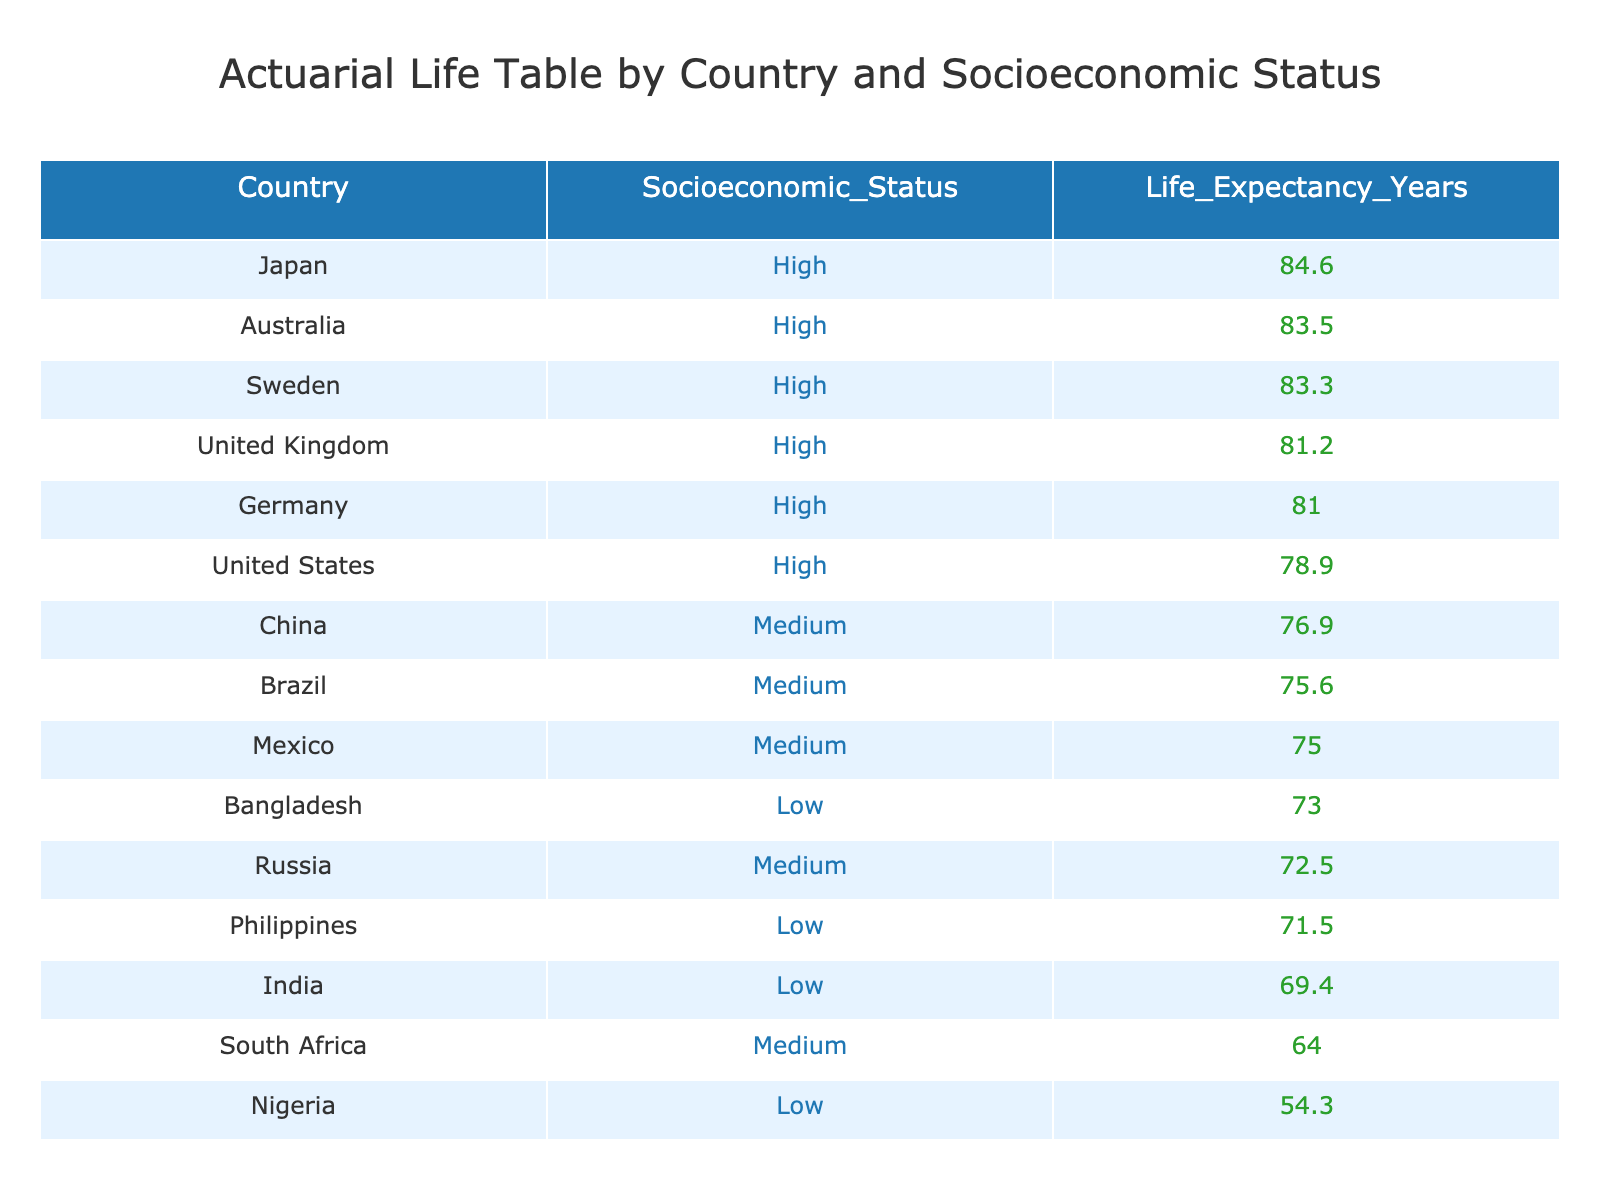What is the life expectancy in Japan? The table indicates that Japan has a life expectancy of 84.6 years.
Answer: 84.6 Which country has the lowest life expectancy? The table shows that Nigeria has the lowest life expectancy at 54.3 years.
Answer: 54.3 What is the average life expectancy for countries with high socioeconomic status? The life expectancy values for high socioeconomic status countries are 84.6 (Japan), 78.9 (United States), 81.0 (Germany), 83.3 (Sweden), and 83.5 (Australia). Summing these gives 84.6 + 78.9 + 81.0 + 83.3 + 83.5 = 411.3. Dividing by 5 gives an average of 82.26.
Answer: 82.26 Is the life expectancy in Brazil higher than that in South Africa? According to the table, Brazil's life expectancy is 75.6 years, while South Africa's is 64.0 years. Therefore, yes, Brazil has a higher life expectancy than South Africa.
Answer: Yes What is the difference in life expectancy between the highest and lowest country? The highest life expectancy is from Japan at 84.6 years, and the lowest is from Nigeria at 54.3 years. The difference is calculated by subtracting the lower value from the higher one: 84.6 - 54.3 = 30.3 years.
Answer: 30.3 How many countries in the table have a medium socioeconomic status and their average life expectancy? The countries with medium socioeconomic status are Brazil, South Africa, China, Mexico, and Russia. Their life expectancies are 75.6, 64.0, 76.9, 75.0, and 72.5, respectively. Summing these gives 75.6 + 64.0 + 76.9 + 75.0 + 72.5 = 364.0. Dividing by 5 gives an average of 72.8.
Answer: 72.8 Does any country with low socioeconomic status have a life expectancy above 70 years? The table shows that India has a life expectancy of 69.4 years, Bangladesh has 73.0 years, and Nigeria has 54.3 years. Thus, only Bangladesh exceeds 70 years, making the answer true.
Answer: Yes Which country has the highest life expectancy among the low socioeconomic status group? In the table, Bangladesh has the highest life expectancy at 73.0 years among the low socioeconomic status countries (India has 69.4 years and Nigeria has 54.3 years).
Answer: 73.0 